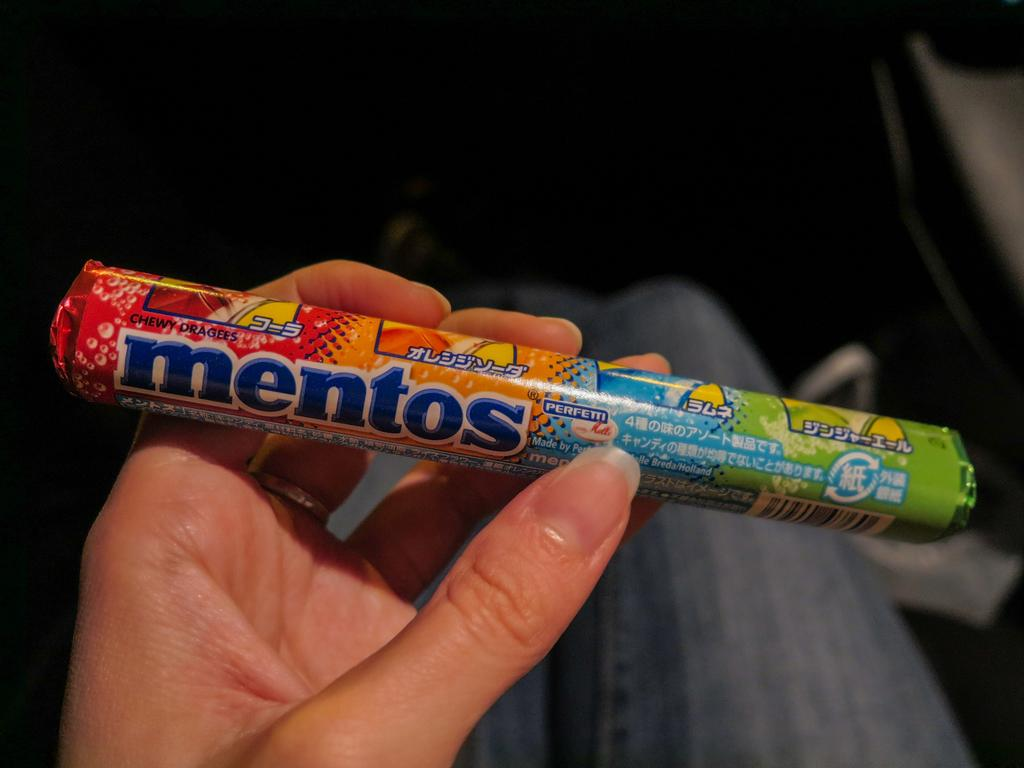What is the main subject of the image? There is a person in the image. What is the person holding in the image? The person is holding mentos. What reward does the person receive for holding the mentos in the image? There is no indication in the image that the person is receiving a reward for holding the mentos. 